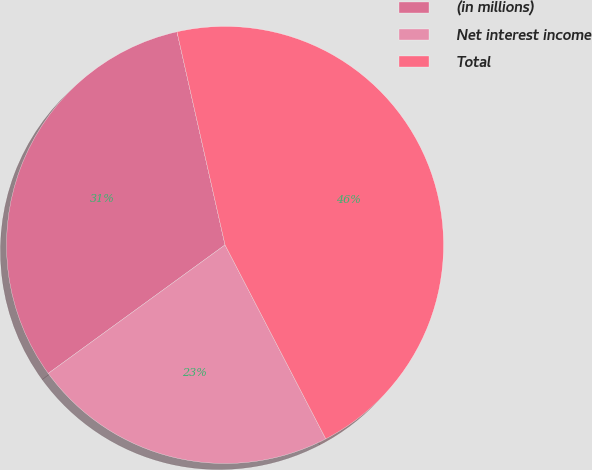Convert chart to OTSL. <chart><loc_0><loc_0><loc_500><loc_500><pie_chart><fcel>(in millions)<fcel>Net interest income<fcel>Total<nl><fcel>31.47%<fcel>22.62%<fcel>45.9%<nl></chart> 